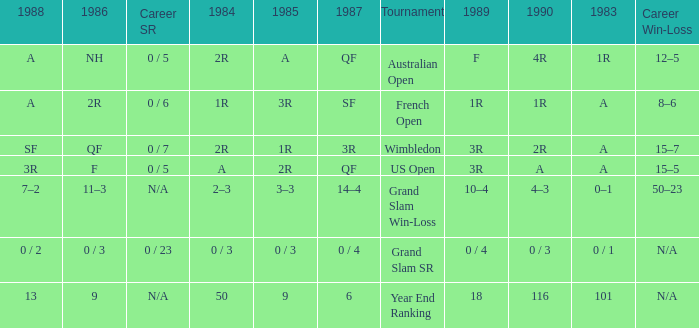With a 1986 of NH and a career SR of 0 / 5 what is the results in 1985? A. 